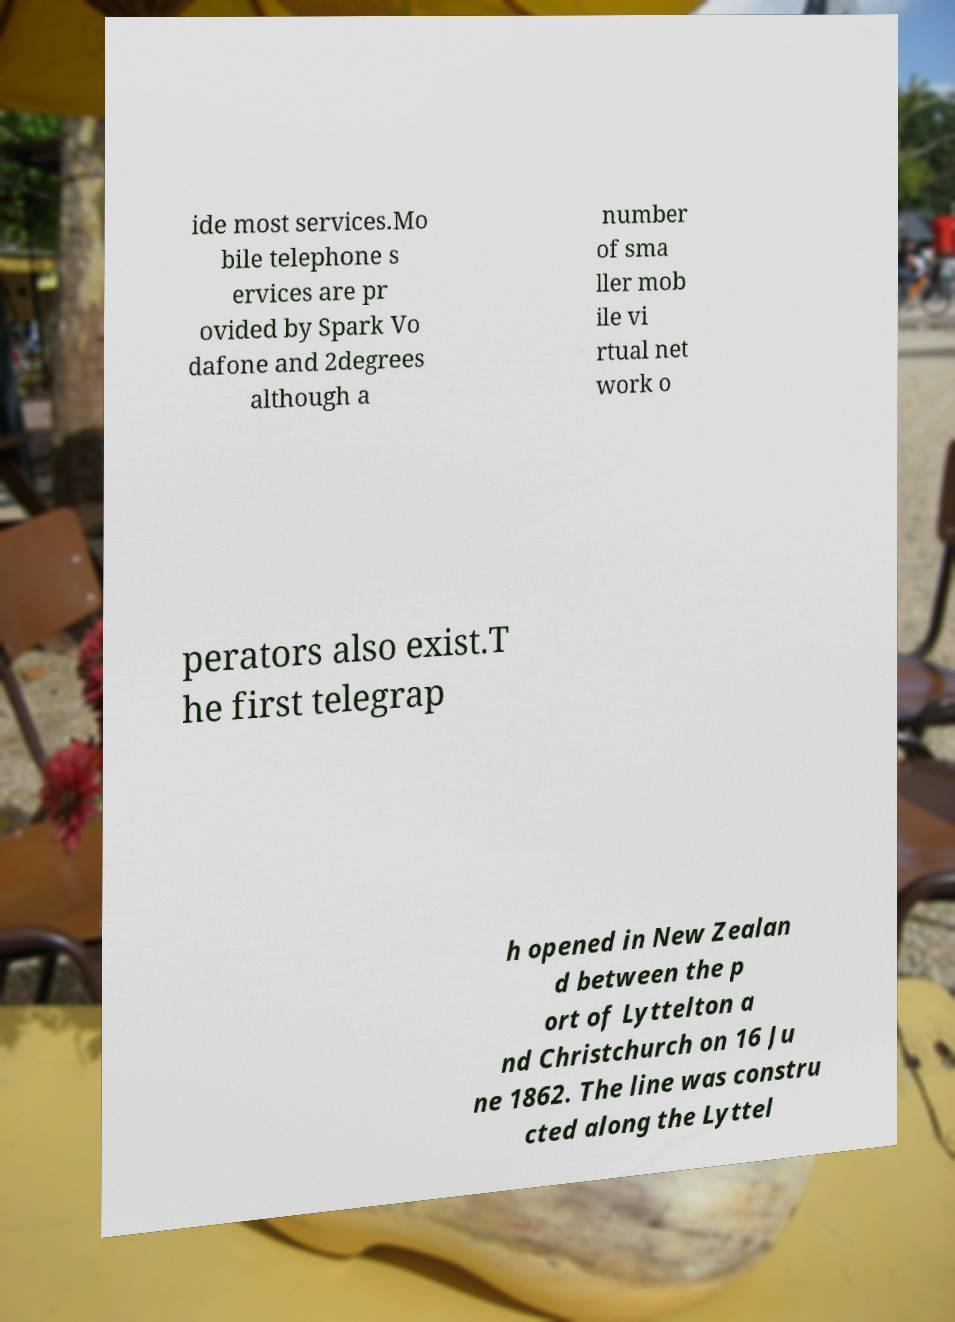What messages or text are displayed in this image? I need them in a readable, typed format. ide most services.Mo bile telephone s ervices are pr ovided by Spark Vo dafone and 2degrees although a number of sma ller mob ile vi rtual net work o perators also exist.T he first telegrap h opened in New Zealan d between the p ort of Lyttelton a nd Christchurch on 16 Ju ne 1862. The line was constru cted along the Lyttel 